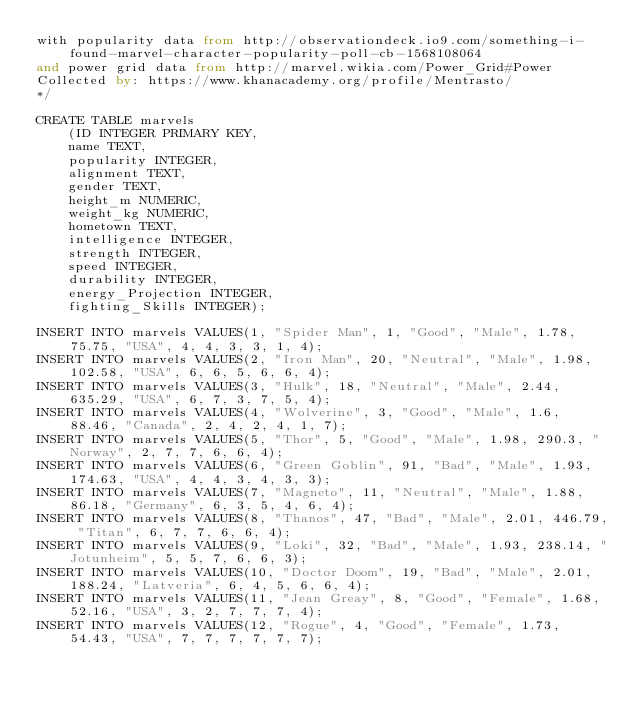Convert code to text. <code><loc_0><loc_0><loc_500><loc_500><_SQL_>with popularity data from http://observationdeck.io9.com/something-i-found-marvel-character-popularity-poll-cb-1568108064 
and power grid data from http://marvel.wikia.com/Power_Grid#Power
Collected by: https://www.khanacademy.org/profile/Mentrasto/
*/

CREATE TABLE marvels 
    (ID INTEGER PRIMARY KEY,
    name TEXT,
    popularity INTEGER,
    alignment TEXT,
    gender TEXT, 
    height_m NUMERIC,
    weight_kg NUMERIC,
    hometown TEXT,
    intelligence INTEGER,
    strength INTEGER,
    speed INTEGER,
    durability INTEGER,
    energy_Projection INTEGER,
    fighting_Skills INTEGER);

INSERT INTO marvels VALUES(1, "Spider Man", 1, "Good", "Male", 1.78, 75.75, "USA", 4, 4, 3, 3, 1, 4); 
INSERT INTO marvels VALUES(2, "Iron Man", 20, "Neutral", "Male", 1.98, 102.58, "USA", 6, 6, 5, 6, 6, 4); 
INSERT INTO marvels VALUES(3, "Hulk", 18, "Neutral", "Male", 2.44, 635.29, "USA", 6, 7, 3, 7, 5, 4); 
INSERT INTO marvels VALUES(4, "Wolverine", 3, "Good", "Male", 1.6, 88.46, "Canada", 2, 4, 2, 4, 1, 7);
INSERT INTO marvels VALUES(5, "Thor", 5, "Good", "Male", 1.98, 290.3, "Norway", 2, 7, 7, 6, 6, 4);
INSERT INTO marvels VALUES(6, "Green Goblin", 91, "Bad", "Male", 1.93, 174.63, "USA", 4, 4, 3, 4, 3, 3);
INSERT INTO marvels VALUES(7, "Magneto", 11, "Neutral", "Male", 1.88, 86.18, "Germany", 6, 3, 5, 4, 6, 4);
INSERT INTO marvels VALUES(8, "Thanos", 47, "Bad", "Male", 2.01, 446.79, "Titan", 6, 7, 7, 6, 6, 4);
INSERT INTO marvels VALUES(9, "Loki", 32, "Bad", "Male", 1.93, 238.14, "Jotunheim", 5, 5, 7, 6, 6, 3);
INSERT INTO marvels VALUES(10, "Doctor Doom", 19, "Bad", "Male", 2.01, 188.24, "Latveria", 6, 4, 5, 6, 6, 4);
INSERT INTO marvels VALUES(11, "Jean Greay", 8, "Good", "Female", 1.68, 52.16, "USA", 3, 2, 7, 7, 7, 4);
INSERT INTO marvels VALUES(12, "Rogue", 4, "Good", "Female", 1.73, 54.43, "USA", 7, 7, 7, 7, 7, 7);

</code> 